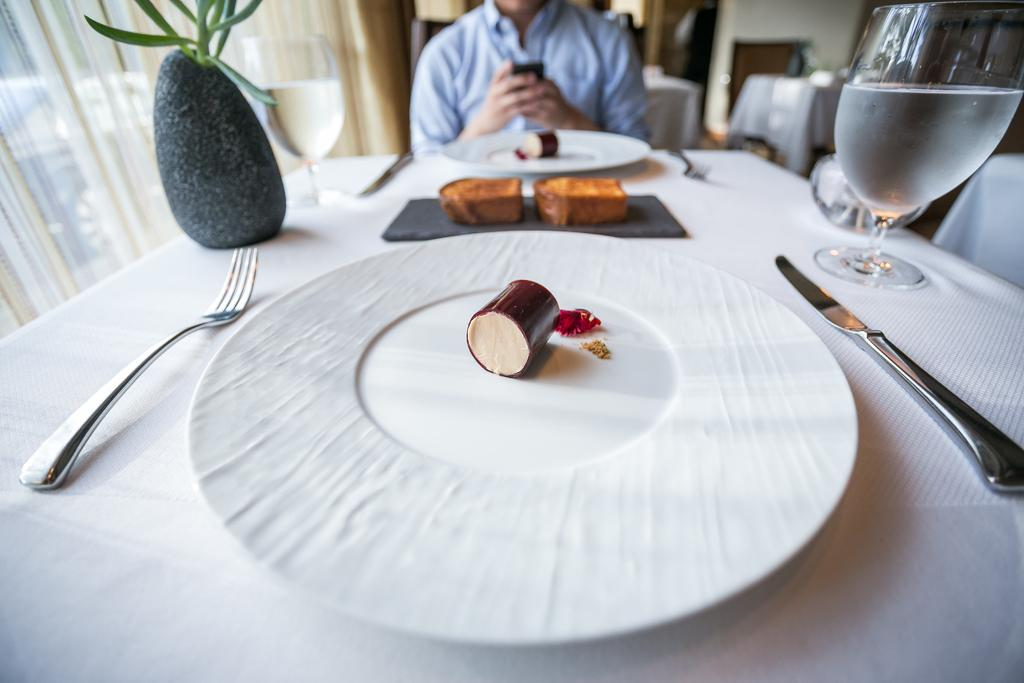What is the person in the image doing? The person is sitting on a chair. What objects are on the table in the image? There is a plate, a fork, a plant, a glass, and food on the table. What might the person be using to eat the food on the table? The fork on the table might be used to eat the food. What type of plant is on the table? The provided facts do not specify the type of plant on the table. How does the wind affect the food on the table in the image? There is no wind present in the image, so it cannot affect the food on the table. 